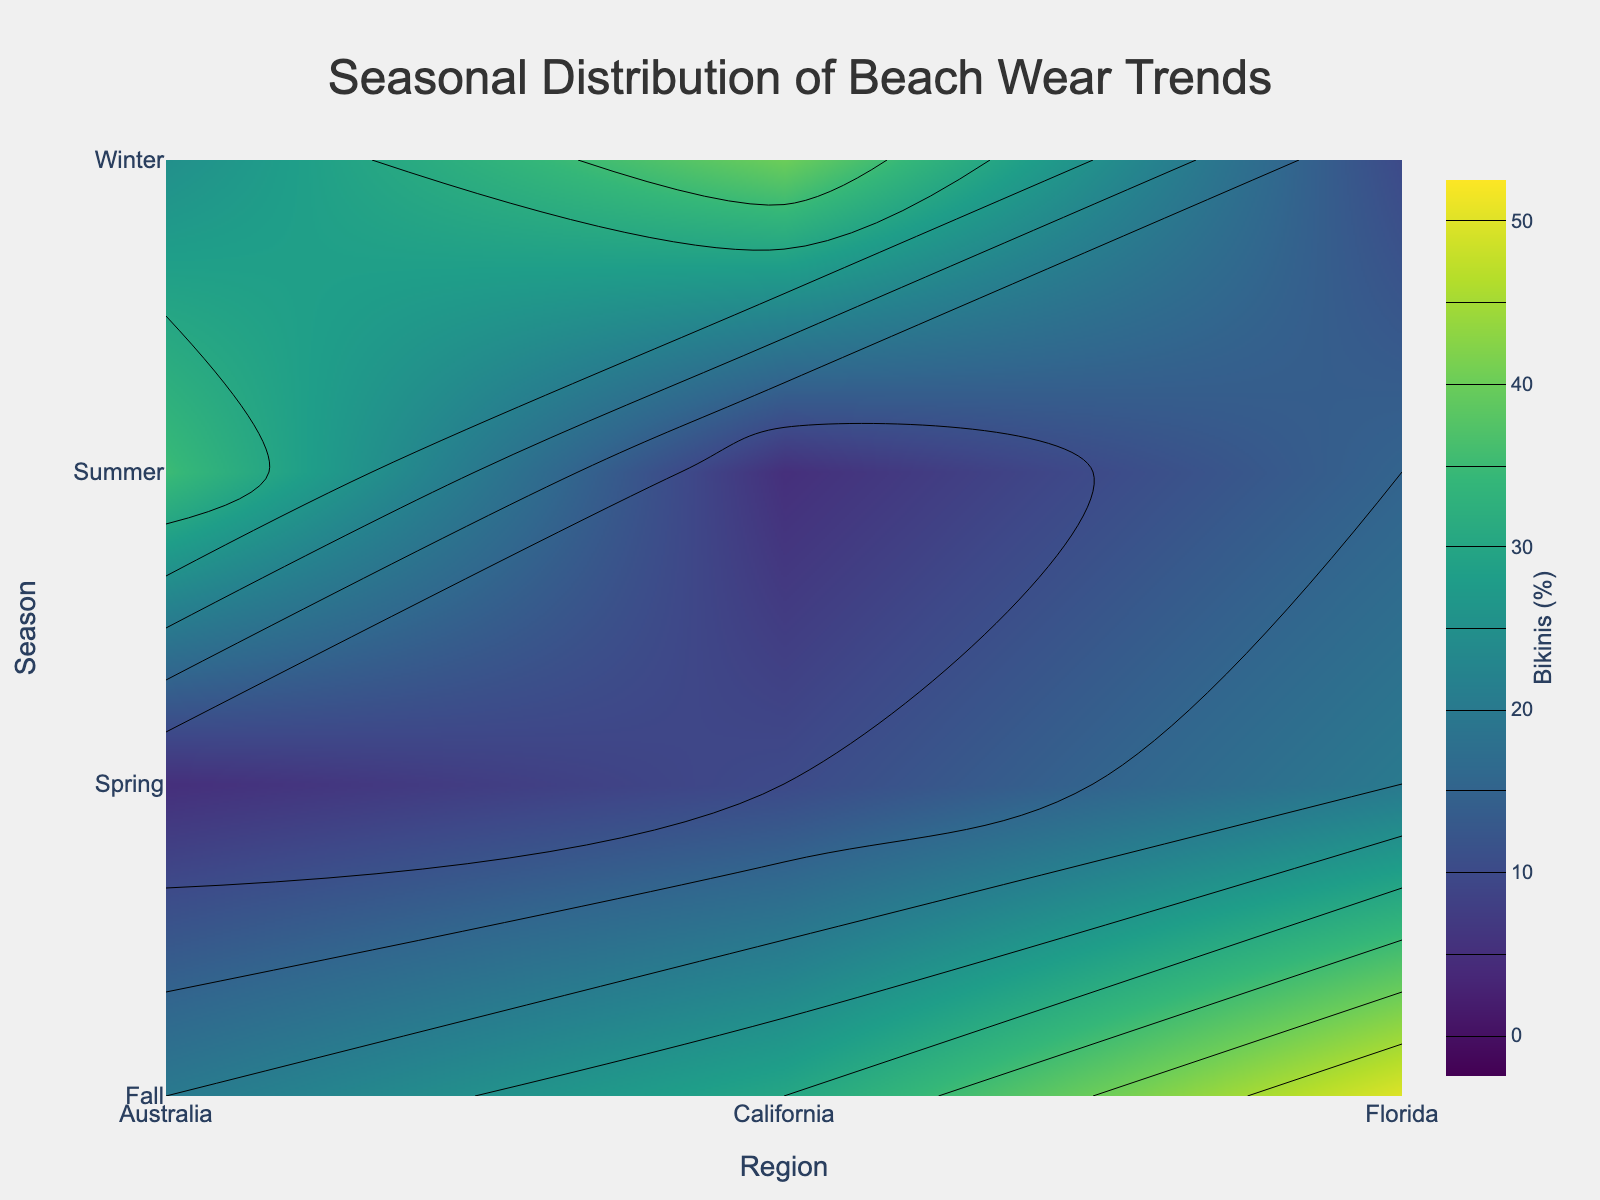How many contour plots are presented on the figure? There are five beach wear trends (Bikinis, Board Shorts, One-Piece Swimsuits, Cover-Ups, Beach Hats) in the data, and each trend has its own contour plot.
Answer: 5 Which beach wear trend is initially visible on the contour plot? The contour plot for 'Bikinis' is set to be initially visible, while others are displayed in the legend.
Answer: Bikinis In which season do California and Florida have the highest percentage for Bikinis? For California, the highest Bikinis percentage is in Summer (35%), while for Florida, it is also Summer but higher (40%).
Answer: Summer Which region shows the highest percentage for Board Shorts in Winter? By examining the contour plots for the Winter season, the highest percentage for Board Shorts is in Australia at 15%.
Answer: Australia What is the average percentage of Cover-Ups in Winter for all regions? To find the average, add the Winter percentages for Cover-Ups in all regions (California: 40%, Florida: 30%, Australia: 30%) and divide by the number of regions: (40% + 30% + 30%) / 3 = 33.3%.
Answer: 33.3% Compare the percentage of One-Piece Swimsuits in Spring for California and Australia. Which is higher? In the Spring season, California has 15% for One-Piece Swimsuits while Australia also has exactly 15%.
Answer: They are equal What is the total percentage of beach hats across all seasons in Florida? Add the beach hats percentages for every season in Florida: Spring (20%) + Summer (10%) + Fall (15%) + Winter (20%) = 65%.
Answer: 65% Across all regions and seasons, which beach wear trend commands the highest single percentage observed? By examining all contour plots and their highest points, the highest single percentage is observed for Bikinis in Summer in Australia at 50%.
Answer: Bikinis in Summer in Australia at 50% Which season shows the highest overall percentage for One-Piece Swimsuits in Florida? From the contour plots, the Winter season in Florida shows the highest percentage for One-Piece Swimsuits at 30%.
Answer: Winter 